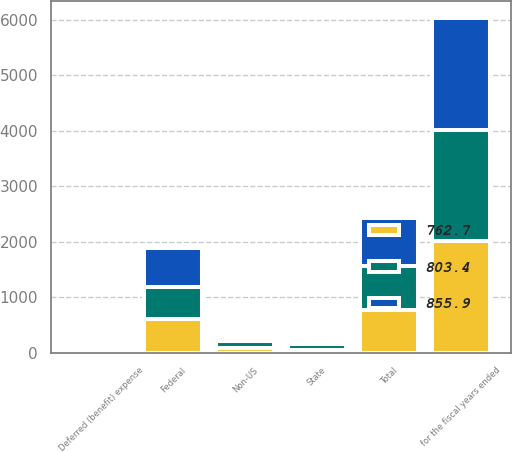Convert chart to OTSL. <chart><loc_0><loc_0><loc_500><loc_500><stacked_bar_chart><ecel><fcel>for the fiscal years ended<fcel>Federal<fcel>State<fcel>Non-US<fcel>Deferred (benefit) expense<fcel>Total<nl><fcel>855.9<fcel>2013<fcel>699.6<fcel>76.8<fcel>85.7<fcel>6.2<fcel>855.9<nl><fcel>762.7<fcel>2012<fcel>602.9<fcel>56.1<fcel>83.2<fcel>20.5<fcel>762.7<nl><fcel>803.4<fcel>2011<fcel>576.4<fcel>103.8<fcel>122.8<fcel>0.4<fcel>803.4<nl></chart> 